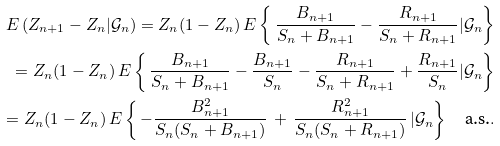Convert formula to latex. <formula><loc_0><loc_0><loc_500><loc_500>E \left ( Z _ { n + 1 } - Z _ { n } | \mathcal { G } _ { n } \right ) = Z _ { n } ( 1 - Z _ { n } ) \, E \left \{ \, \frac { B _ { n + 1 } } { S _ { n } + B _ { n + 1 } } - \frac { R _ { n + 1 } } { S _ { n } + R _ { n + 1 } } | \mathcal { G } _ { n } \right \} \\ = Z _ { n } ( 1 - Z _ { n } ) \, E \left \{ \, \frac { B _ { n + 1 } } { S _ { n } + B _ { n + 1 } } - \frac { B _ { n + 1 } } { S _ { n } } - \frac { R _ { n + 1 } } { S _ { n } + R _ { n + 1 } } + \frac { R _ { n + 1 } } { S _ { n } } | \mathcal { G } _ { n } \right \} \\ = Z _ { n } ( 1 - Z _ { n } ) \, E \left \{ \, - \frac { B _ { n + 1 } ^ { 2 } } { S _ { n } ( S _ { n } + B _ { n + 1 } ) } \, + \, \frac { R _ { n + 1 } ^ { 2 } } { S _ { n } ( S _ { n } + R _ { n + 1 } ) } \, | \mathcal { G } _ { n } \right \} \quad \text {a.s.} .</formula> 